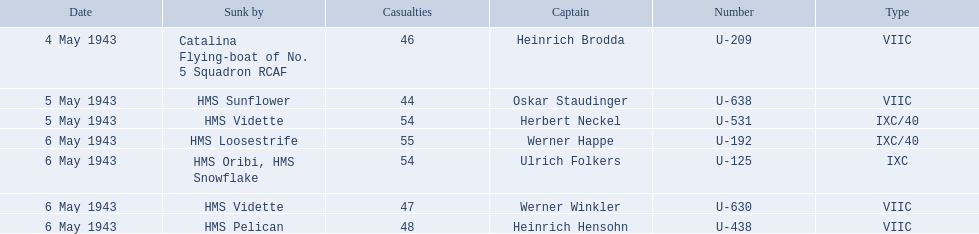What boats were lost on may 5? U-638, U-531. Who were the captains of those boats? Oskar Staudinger, Herbert Neckel. Which captain was not oskar staudinger? Herbert Neckel. Which were the names of the sinkers of the convoys? Catalina Flying-boat of No. 5 Squadron RCAF, HMS Sunflower, HMS Vidette, HMS Loosestrife, HMS Oribi, HMS Snowflake, HMS Vidette, HMS Pelican. What captain was sunk by the hms pelican? Heinrich Hensohn. 